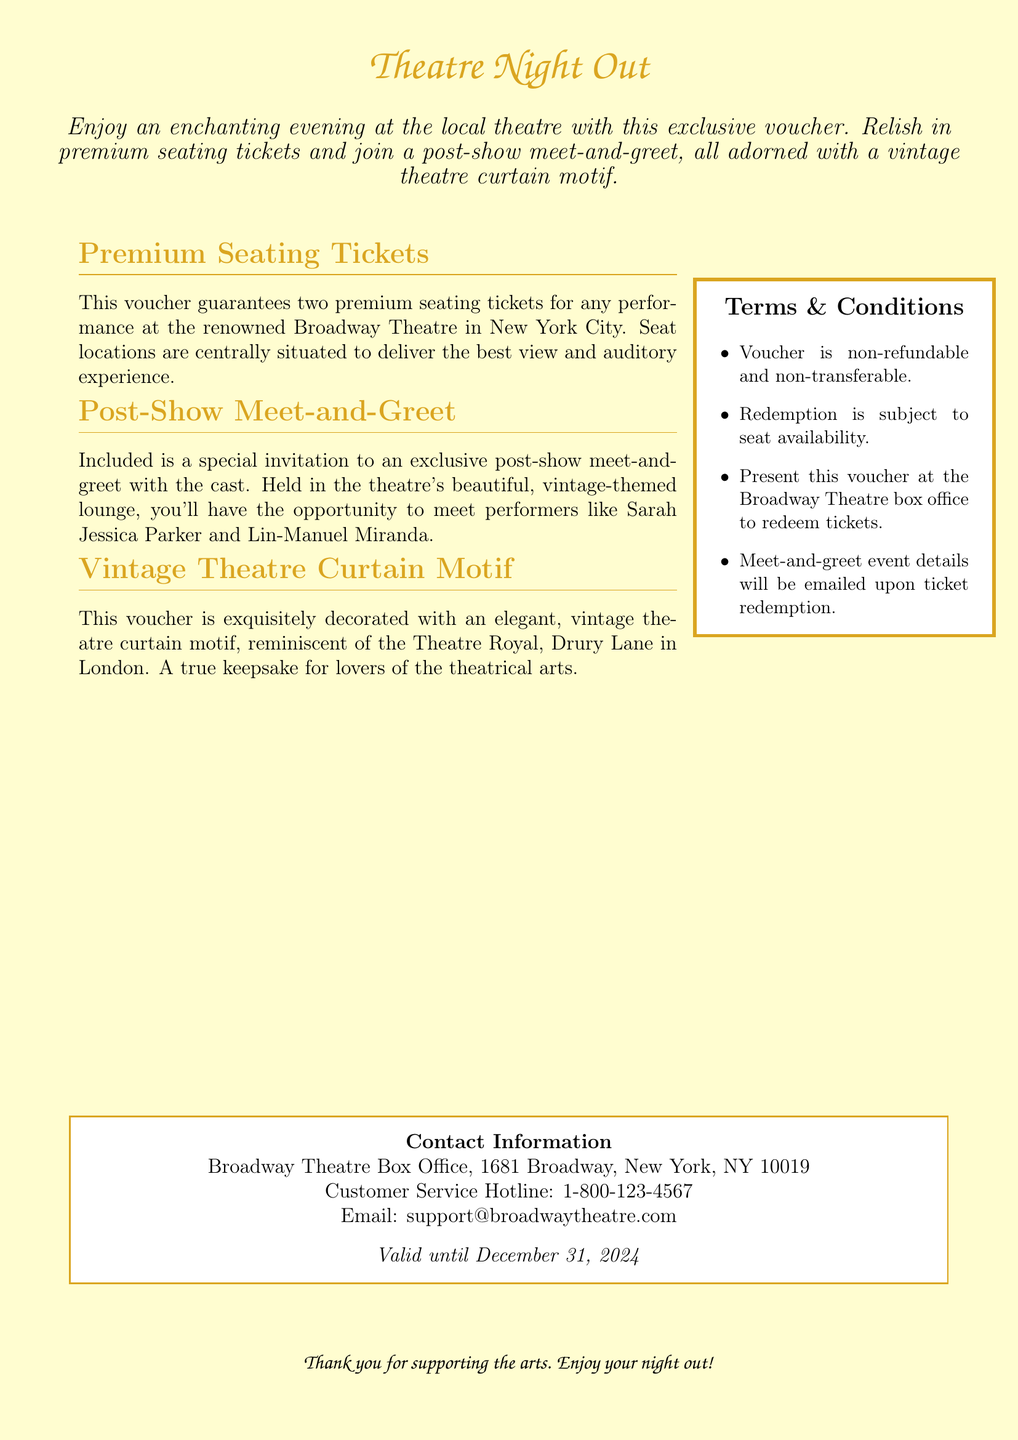What is included in the voucher? The voucher includes premium seating tickets and a post-show meet-and-greet invitation.
Answer: Premium seating tickets and a post-show meet-and-greet invitation Where is the voucher valid? The voucher is valid for performances at the Broadway Theatre.
Answer: Broadway Theatre, New York City Who can attendees meet at the post-show meet-and-greet? Attendees can meet performers like Sarah Jessica Parker and Lin-Manuel Miranda.
Answer: Sarah Jessica Parker and Lin-Manuel Miranda What is the expiration date of the voucher? The voucher is valid until December 31, 2024.
Answer: December 31, 2024 What type of motif decorates the voucher? The voucher is decorated with a vintage theatre curtain motif.
Answer: Vintage theatre curtain motif What is the customer service hotline number? The customer service hotline number is provided for assistance.
Answer: 1-800-123-4567 Is the voucher transferable? The terms state that the voucher is non-transferable.
Answer: Non-transferable What are the seating locations for the tickets? The voucher guarantees centrally situated seat locations for the best experience.
Answer: Centrally situated 